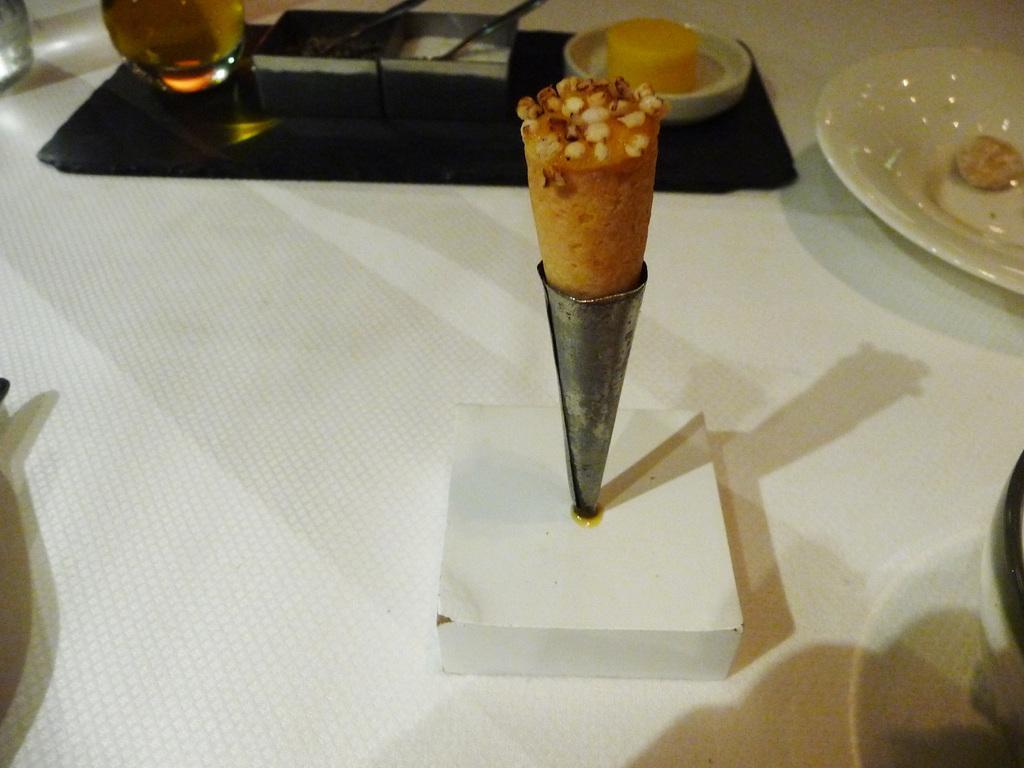In one or two sentences, can you explain what this image depicts? At the bottom of the image there is a white surface. On the surface there is a white box with cone shape. And at the top of the image there is a black tray with few items on it. At the top right corner of the image there is a white plate. 